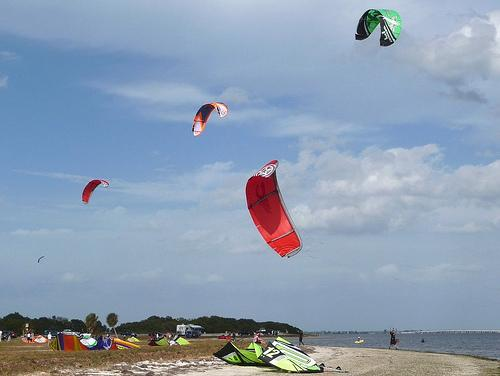The inflatable wing used to fly in which game? Please explain your reasoning. paragliding. People would parachute out of a plane and wings are not used in skating.  kites do not pick up people. 